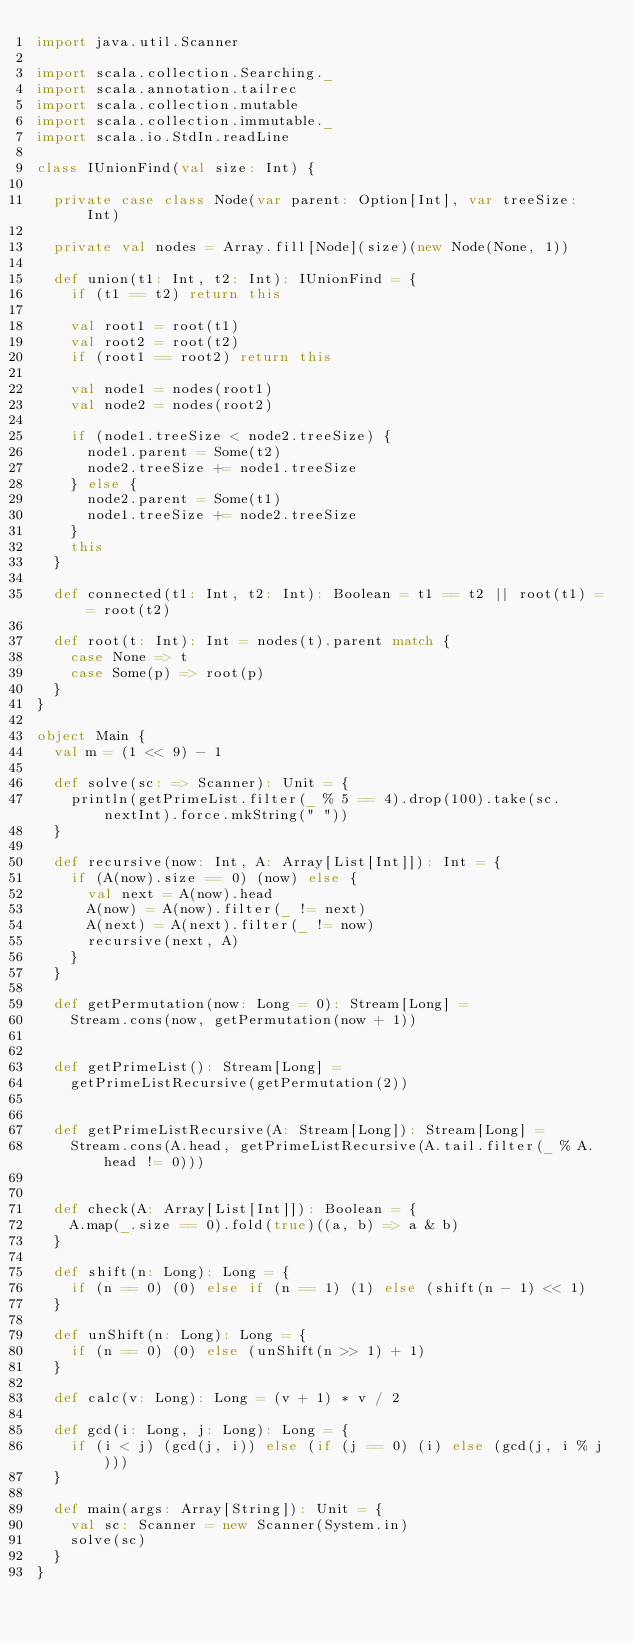<code> <loc_0><loc_0><loc_500><loc_500><_Scala_>import java.util.Scanner

import scala.collection.Searching._
import scala.annotation.tailrec
import scala.collection.mutable
import scala.collection.immutable._
import scala.io.StdIn.readLine

class IUnionFind(val size: Int) {

  private case class Node(var parent: Option[Int], var treeSize: Int)

  private val nodes = Array.fill[Node](size)(new Node(None, 1))

  def union(t1: Int, t2: Int): IUnionFind = {
    if (t1 == t2) return this

    val root1 = root(t1)
    val root2 = root(t2)
    if (root1 == root2) return this

    val node1 = nodes(root1)
    val node2 = nodes(root2)

    if (node1.treeSize < node2.treeSize) {
      node1.parent = Some(t2)
      node2.treeSize += node1.treeSize
    } else {
      node2.parent = Some(t1)
      node1.treeSize += node2.treeSize
    }
    this
  }

  def connected(t1: Int, t2: Int): Boolean = t1 == t2 || root(t1) == root(t2)

  def root(t: Int): Int = nodes(t).parent match {
    case None => t
    case Some(p) => root(p)
  }
}

object Main {
  val m = (1 << 9) - 1

  def solve(sc: => Scanner): Unit = {
    println(getPrimeList.filter(_ % 5 == 4).drop(100).take(sc.nextInt).force.mkString(" "))
  }

  def recursive(now: Int, A: Array[List[Int]]): Int = {
    if (A(now).size == 0) (now) else {
      val next = A(now).head
      A(now) = A(now).filter(_ != next)
      A(next) = A(next).filter(_ != now)
      recursive(next, A)
    }
  }

  def getPermutation(now: Long = 0): Stream[Long] =
    Stream.cons(now, getPermutation(now + 1))


  def getPrimeList(): Stream[Long] =
    getPrimeListRecursive(getPermutation(2))


  def getPrimeListRecursive(A: Stream[Long]): Stream[Long] =
    Stream.cons(A.head, getPrimeListRecursive(A.tail.filter(_ % A.head != 0)))


  def check(A: Array[List[Int]]): Boolean = {
    A.map(_.size == 0).fold(true)((a, b) => a & b)
  }

  def shift(n: Long): Long = {
    if (n == 0) (0) else if (n == 1) (1) else (shift(n - 1) << 1)
  }

  def unShift(n: Long): Long = {
    if (n == 0) (0) else (unShift(n >> 1) + 1)
  }

  def calc(v: Long): Long = (v + 1) * v / 2

  def gcd(i: Long, j: Long): Long = {
    if (i < j) (gcd(j, i)) else (if (j == 0) (i) else (gcd(j, i % j)))
  }

  def main(args: Array[String]): Unit = {
    val sc: Scanner = new Scanner(System.in)
    solve(sc)
  }
}</code> 